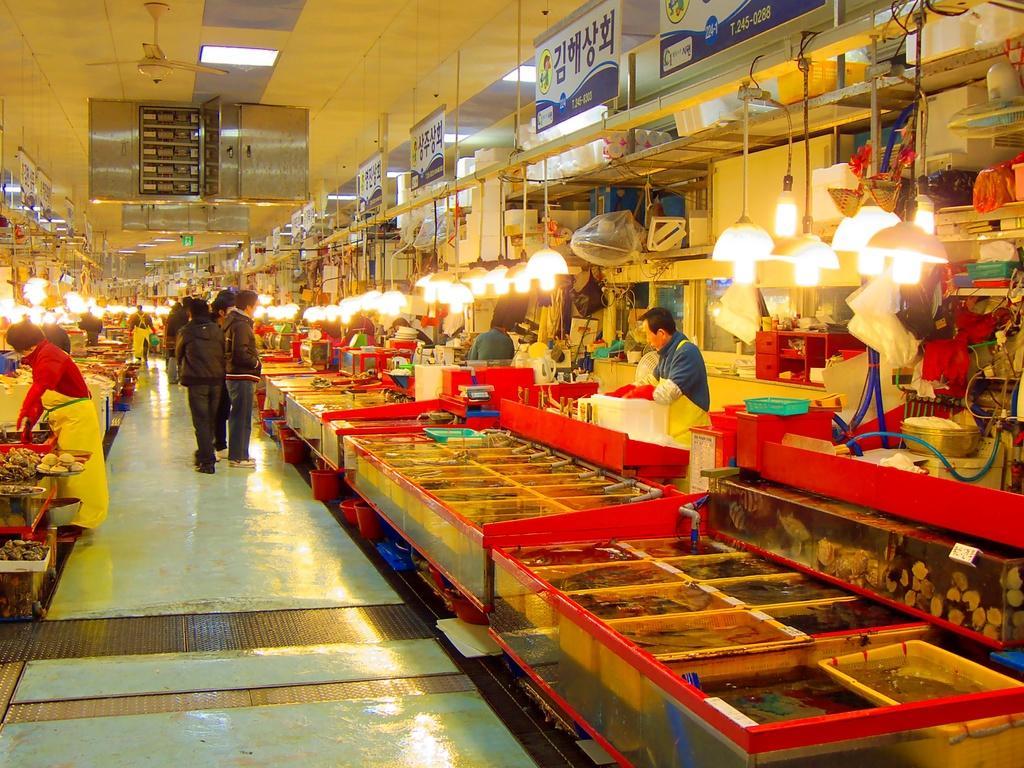Please provide a concise description of this image. In this image, we can see few people, lights, some objects, containers, things, banners, rods, wall. Top of the image, there is a ceiling, lights, fan, few boxes. At the bottom, there is a walkway. 